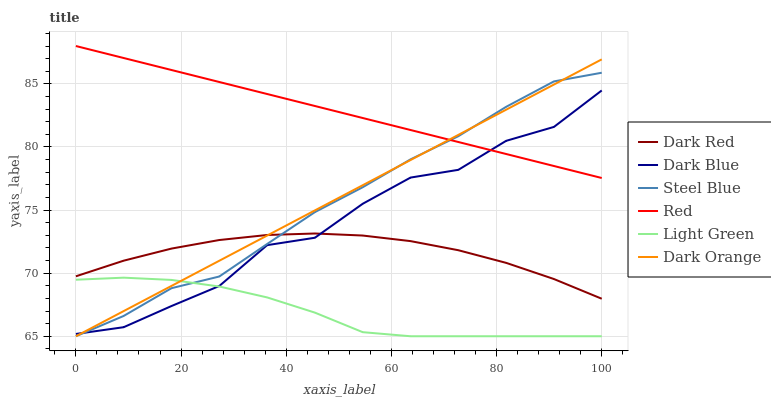Does Light Green have the minimum area under the curve?
Answer yes or no. Yes. Does Red have the maximum area under the curve?
Answer yes or no. Yes. Does Dark Red have the minimum area under the curve?
Answer yes or no. No. Does Dark Red have the maximum area under the curve?
Answer yes or no. No. Is Red the smoothest?
Answer yes or no. Yes. Is Dark Blue the roughest?
Answer yes or no. Yes. Is Dark Red the smoothest?
Answer yes or no. No. Is Dark Red the roughest?
Answer yes or no. No. Does Dark Orange have the lowest value?
Answer yes or no. Yes. Does Dark Red have the lowest value?
Answer yes or no. No. Does Red have the highest value?
Answer yes or no. Yes. Does Dark Red have the highest value?
Answer yes or no. No. Is Dark Red less than Red?
Answer yes or no. Yes. Is Red greater than Light Green?
Answer yes or no. Yes. Does Red intersect Dark Blue?
Answer yes or no. Yes. Is Red less than Dark Blue?
Answer yes or no. No. Is Red greater than Dark Blue?
Answer yes or no. No. Does Dark Red intersect Red?
Answer yes or no. No. 